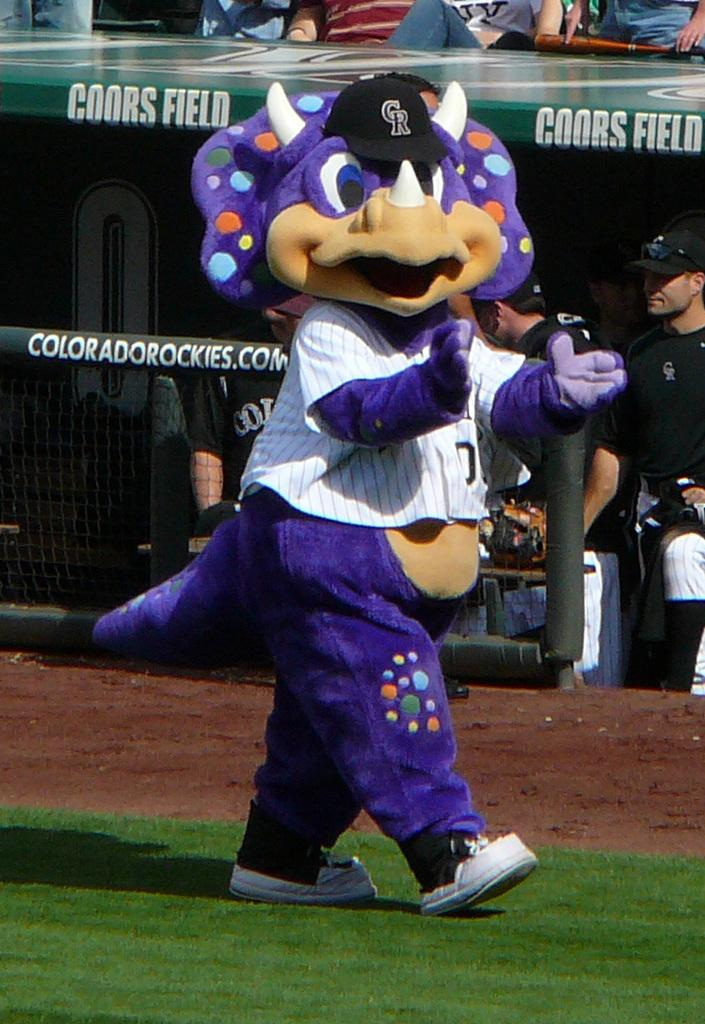<image>
Share a concise interpretation of the image provided. a dinosaur mascot on a coors field baseball field 